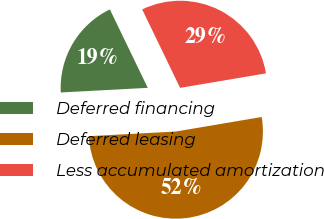Convert chart. <chart><loc_0><loc_0><loc_500><loc_500><pie_chart><fcel>Deferred financing<fcel>Deferred leasing<fcel>Less accumulated amortization<nl><fcel>18.68%<fcel>51.82%<fcel>29.5%<nl></chart> 